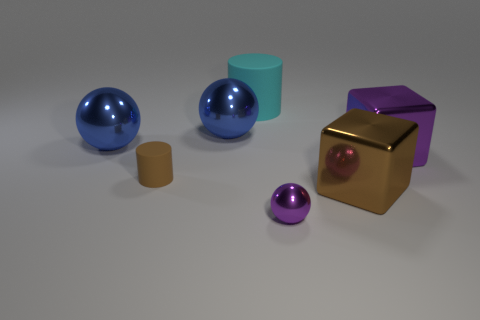There is a cylinder that is right of the small cylinder; what is its color?
Keep it short and to the point. Cyan. Is the number of purple metallic blocks behind the purple metallic sphere the same as the number of small metallic balls?
Keep it short and to the point. Yes. The metallic thing that is both to the right of the brown matte cylinder and to the left of the small purple object has what shape?
Your answer should be compact. Sphere. What color is the other object that is the same shape as the tiny brown thing?
Give a very brief answer. Cyan. Is there any other thing of the same color as the small metal ball?
Offer a terse response. Yes. The purple metallic thing that is behind the metallic sphere that is in front of the matte cylinder that is in front of the large matte object is what shape?
Keep it short and to the point. Cube. Is the size of the cube that is to the right of the big brown metal thing the same as the thing in front of the brown cube?
Keep it short and to the point. No. What number of big cyan objects have the same material as the tiny cylinder?
Offer a terse response. 1. There is a brown object in front of the tiny brown thing on the left side of the tiny purple sphere; how many big shiny things are on the right side of it?
Your response must be concise. 1. Is the brown matte object the same shape as the small purple metallic thing?
Keep it short and to the point. No. 